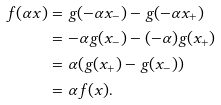<formula> <loc_0><loc_0><loc_500><loc_500>f ( \alpha x ) & = g ( - \alpha x _ { - } ) - g ( - \alpha x _ { + } ) \\ & = - \alpha g ( x _ { - } ) - ( - \alpha ) g ( x _ { + } ) \\ & = \alpha ( g ( x _ { + } ) - g ( x _ { - } ) ) \\ & = \alpha f ( x ) .</formula> 